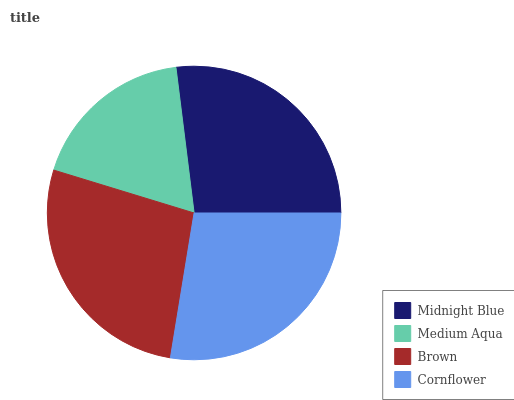Is Medium Aqua the minimum?
Answer yes or no. Yes. Is Cornflower the maximum?
Answer yes or no. Yes. Is Brown the minimum?
Answer yes or no. No. Is Brown the maximum?
Answer yes or no. No. Is Brown greater than Medium Aqua?
Answer yes or no. Yes. Is Medium Aqua less than Brown?
Answer yes or no. Yes. Is Medium Aqua greater than Brown?
Answer yes or no. No. Is Brown less than Medium Aqua?
Answer yes or no. No. Is Brown the high median?
Answer yes or no. Yes. Is Midnight Blue the low median?
Answer yes or no. Yes. Is Midnight Blue the high median?
Answer yes or no. No. Is Cornflower the low median?
Answer yes or no. No. 